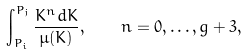<formula> <loc_0><loc_0><loc_500><loc_500>\int _ { P _ { i } } ^ { P _ { j } } \frac { K ^ { n } d K } { \mu ( K ) } , \quad n = 0 , \dots , g + 3 ,</formula> 